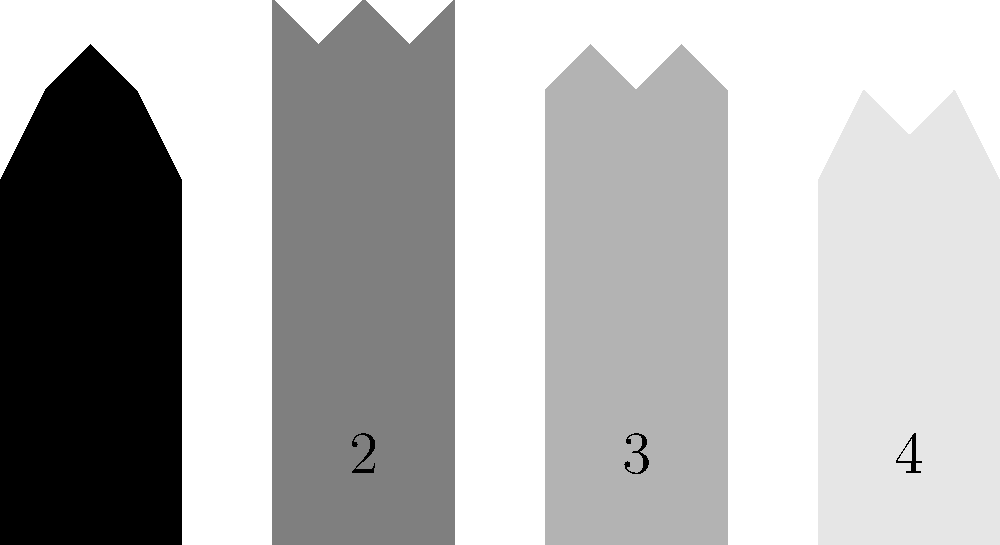Identify the classic movie scene represented by silhouette 2 in the image above. Which iconic film does this outline depict? To identify the movie scene represented by silhouette 2, let's analyze the characteristics of the outline:

1. The silhouette shows a vertical rectangular shape, suggesting a confined space.
2. There are jagged lines at the top of the rectangle, indicating movement or disturbance.
3. The overall shape and composition are reminiscent of a shower curtain or shower stall.

These elements point to one of the most famous scenes in cinema history:

4. The shower scene from Alfred Hitchcock's 1960 psychological thriller "Psycho."
5. This scene is known for its innovative editing techniques and shocking violence for its time.
6. The silhouette captures the moment of the attack, with the jagged lines representing the shower curtain being pulled aside or the violent motion of the attacker.

As a film studies major introducing classic films to an 8-year-old, you would recognize this iconic scene while also being mindful of its mature content when discussing it with a young audience.
Answer: Psycho 